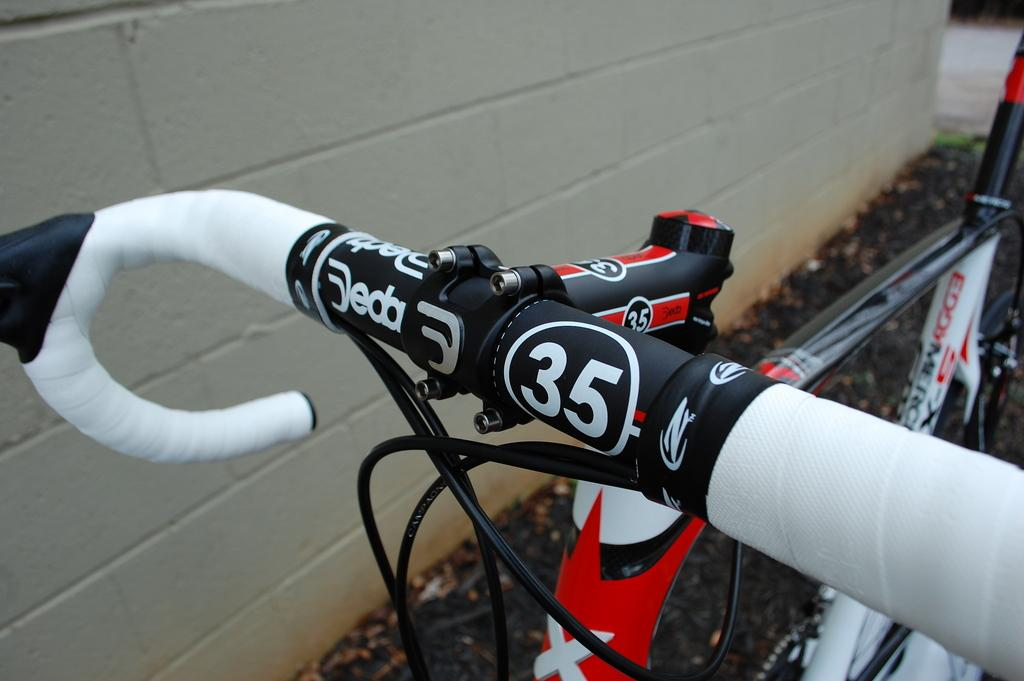What is the main object in the image? There is a bicycle in the image. Where is the bicycle located? The bicycle is on the road. What can be seen beside the road in the image? There is a wall beside the road in the image. What type of bread can be seen on the bicycle in the image? A: There is no bread present on the bicycle in the image; it only features a bicycle on the road with a wall beside it. 